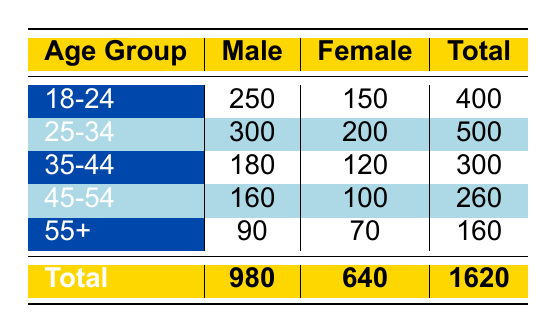What is the total attendance for the age group 25-34? To find the total attendance for the age group 25-34, we need to look at the row corresponding to that age group. The attendance for males is 300 and for females is 200. So, we add these values together: 300 + 200 = 500.
Answer: 500 What is the attendance of female supporters in the 35-44 age group? The attendance for female supporters in the 35-44 age group can be found in the relevant row. It shows that there are 120 female attendees. Therefore, the attendance of female supporters in this age group is 120.
Answer: 120 Is the total attendance for males greater than that for females? To determine if the total attendance for males is greater than for females, we need to compare the total values in the last row of the table. The total attendance for males is 980 and for females is 640. Since 980 is greater than 640, the statement is true.
Answer: Yes What is the average attendance for all age groups combined? To find the average attendance, we take the sum of total attendance across all age groups and divide it by the number of age groups. The total attendance is 1620 and there are 5 age groups. So, the average is 1620 divided by 5, which equals 324.
Answer: 324 How many more male attendees there are in the age group 25-34 compared to 35-44? To calculate the difference, we first identify the number of male attendees in both age groups. In the 25-34 age group, there are 300 male attendees, while in the 35-44 age group, there are 180. We subtract 180 from 300, resulting in a difference of 120 more male attendees in the 25-34 group compared to the 35-44 group.
Answer: 120 What percentage of the total attendance is accounted for by the 45-54 age group? To determine the percentage of total attendance from the 45-54 age group, we first find the total attendance for that group, which is 160 (adding 160 males and 100 females). Then, we divide that by the total attendance of 1620 and multiply by 100 to convert to percentage: (260/1620) * 100 ≈ 16.05%.
Answer: 16.05% Are there more female attendees in the age group 18-24 than in the age group 35-44? We compare the female attendees in both age groups. There are 150 female attendees in the 18-24 age group and 120 in the 35-44 age group. Since 150 is greater than 120, the answer is yes.
Answer: Yes What is the combined attendance of all female supporters across all age groups? To find the combined attendance of female supporters, we add the attendance for females from each age group: 150 (18-24) + 200 (25-34) + 120 (35-44) + 100 (45-54) + 70 (55+) = 740. Hence, the combined attendance of all female supporters is 740.
Answer: 740 